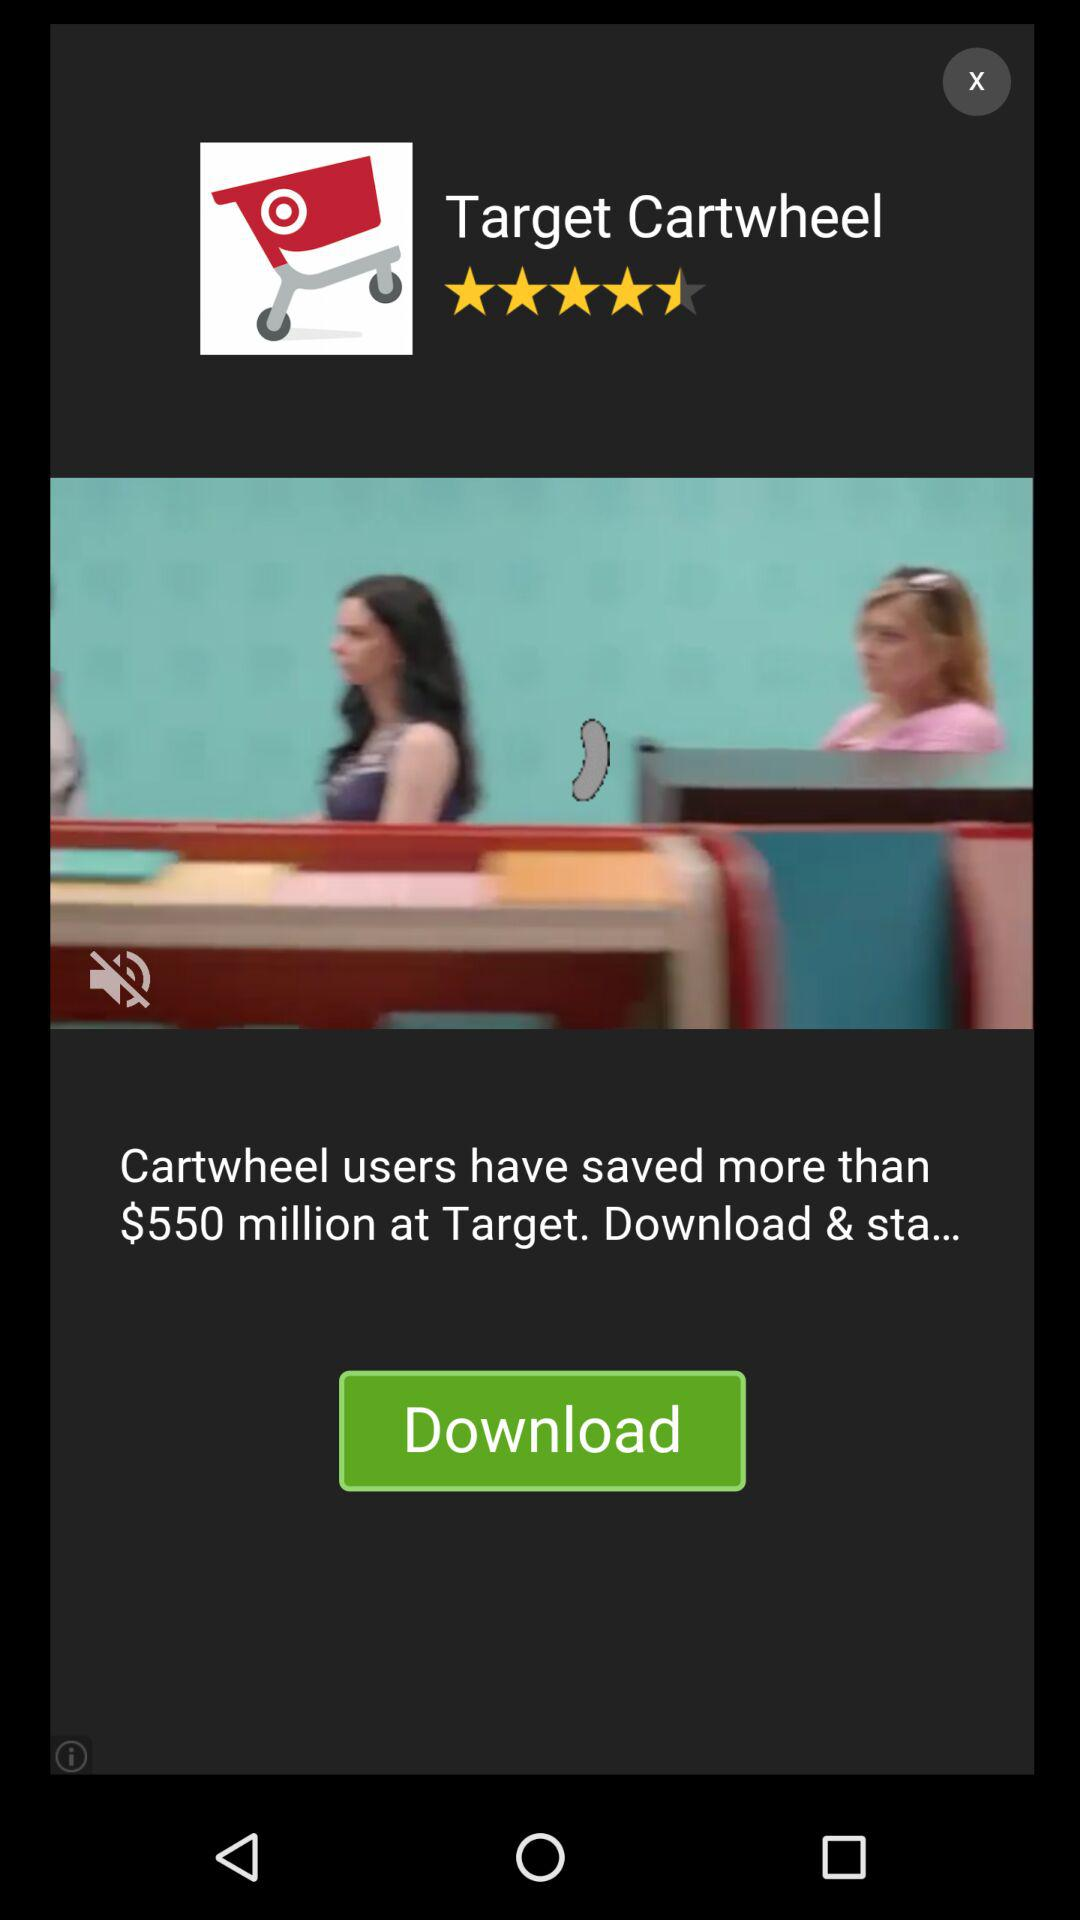What is the rating of the "Target Cartwheel"? The rating of the "Target Cartwheel" is 4.5. 